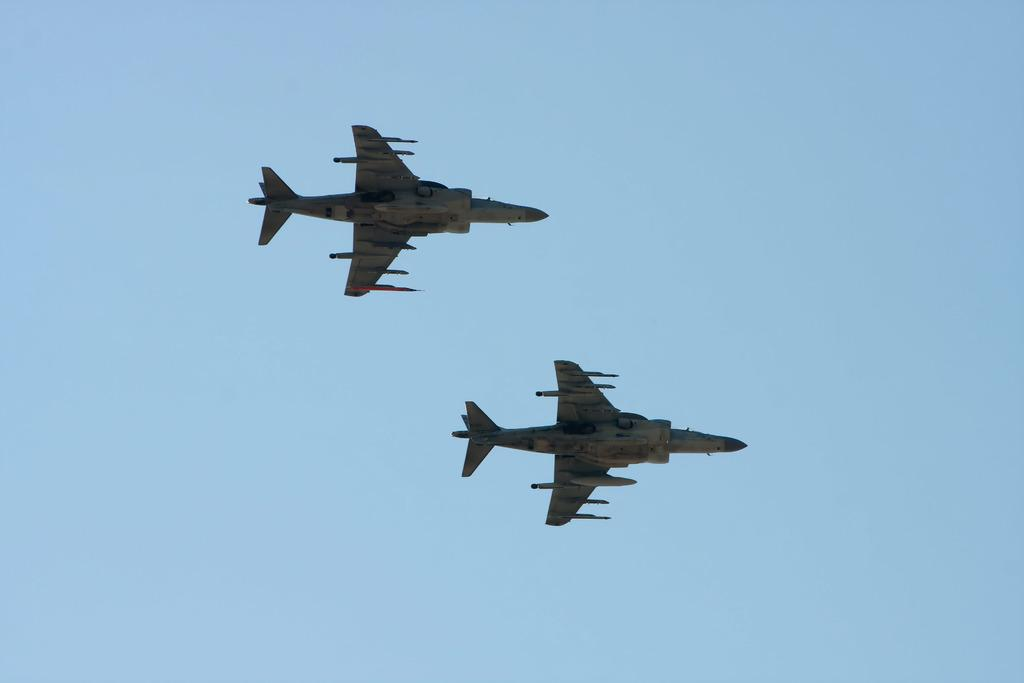What is the main subject of the image? The main subject of the image is aircraft. What are the aircraft doing in the image? The aircraft are flying in the sky. What type of plants can be seen growing on the aircraft in the image? There are no plants visible on the aircraft in the image. Is there a cobweb present in the image? There is no cobweb present in the image. 